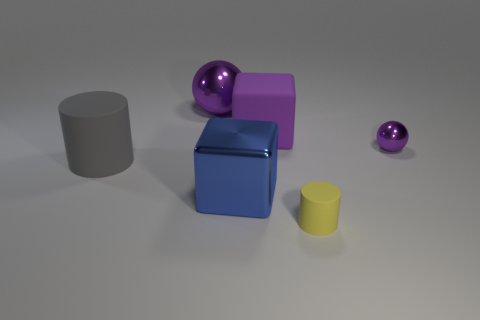Add 1 large metal objects. How many objects exist? 7 Subtract all balls. How many objects are left? 4 Subtract 0 blue cylinders. How many objects are left? 6 Subtract all big rubber cylinders. Subtract all big purple matte objects. How many objects are left? 4 Add 3 small matte things. How many small matte things are left? 4 Add 6 big purple matte balls. How many big purple matte balls exist? 6 